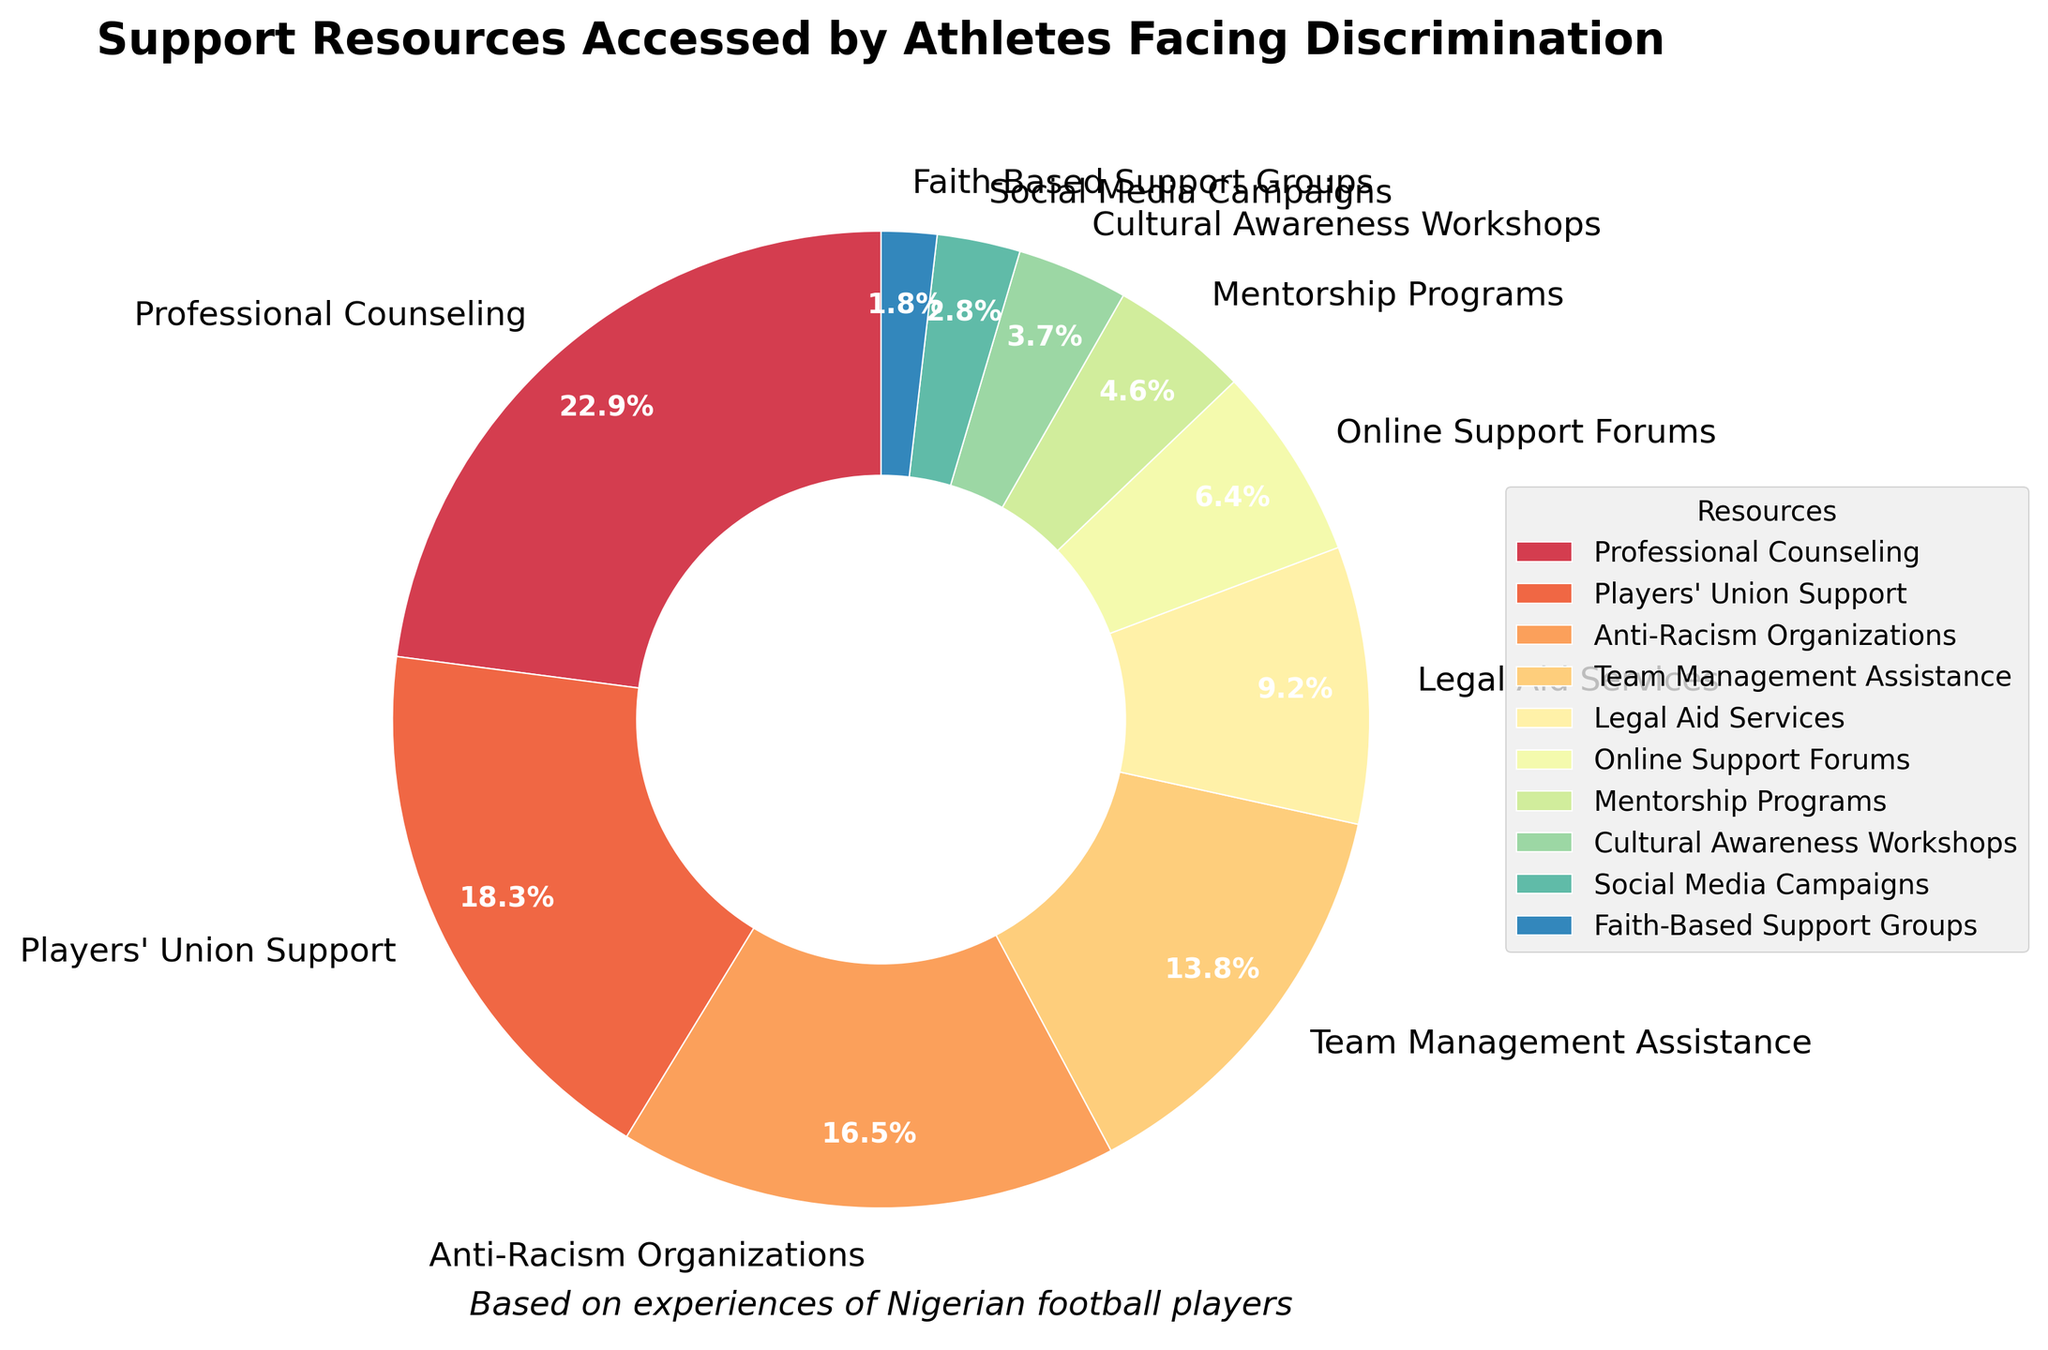What resource is accessed the most? The largest slice of the pie chart represents "Professional Counseling" with a percentage of 25%. This indicates it is the most accessed support resource.
Answer: Professional Counseling Which resource has the smallest percentage? The smallest slice of the pie chart represents "Faith-Based Support Groups" with a percentage of 2%.
Answer: Faith-Based Support Groups How much more popular is Online Support Forums compared to Mentorship Programs? Online Support Forums have a percentage of 7%, while Mentorship Programs have 5%. The difference between these is 7% - 5% = 2%.
Answer: 2% What is the combined percentage of Team Management Assistance and Legal Aid Services? Team Management Assistance has 15% and Legal Aid Services have 10%. Adding these together gives 15% + 10% = 25%.
Answer: 25% Rank the top three resources accessed by athletes facing discrimination. The top three resources by percentages are "Professional Counseling" (25%), "Players' Union Support" (20%), and "Anti-Racism Organizations" (18%).
Answer: Professional Counseling, Players' Union Support, Anti-Racism Organizations Which resources have a percentage less than 5%? The resources with percentages less than 5% are Mentorship Programs (5%), Cultural Awareness Workshops (4%), Social Media Campaigns (3%), and Faith-Based Support Groups (2%).
Answer: Mentorship Programs, Cultural Awareness Workshops, Social Media Campaigns, Faith-Based Support Groups By how much does the percentage of Professional Counseling surpass Anti-Racism Organizations? Professional Counseling is at 25% while Anti-Racism Organizations are at 18%. The difference is 25% - 18% = 7%.
Answer: 7% Add up the percentages of all resources with more than 10%. The resources with percentages more than 10% are Professional Counseling (25%), Players' Union Support (20%), Anti-Racism Organizations (18%), and Team Management Assistance (15%). Adding these gives 25% + 20% + 18% + 15% = 78%.
Answer: 78% Identify the resource represented by the second smallest slice in the pie chart. The second smallest slice represents "Social Media Campaigns" with a percentage of 3%.
Answer: Social Media Campaigns 